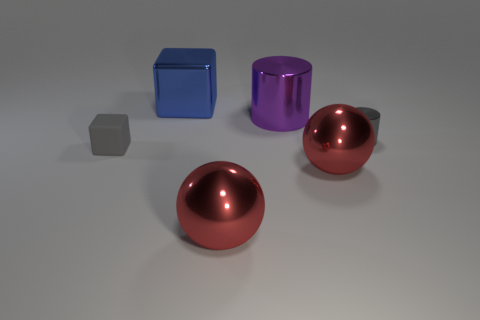There is a metallic object that is the same color as the tiny rubber object; what is its size?
Keep it short and to the point. Small. There is a tiny block; is its color the same as the tiny object that is on the right side of the large blue shiny cube?
Provide a short and direct response. Yes. What color is the large thing that is both on the right side of the shiny block and behind the gray cube?
Provide a short and direct response. Purple. How many purple shiny cylinders are behind the large block?
Keep it short and to the point. 0. What number of things are green metal objects or small objects left of the large blue metal block?
Offer a terse response. 1. There is a shiny cube left of the tiny gray cylinder; is there a big red sphere that is left of it?
Your answer should be very brief. No. There is a block that is behind the tiny gray cube; what color is it?
Give a very brief answer. Blue. Is the number of tiny gray matte cubes behind the small metal cylinder the same as the number of big gray matte balls?
Provide a succinct answer. Yes. What shape is the thing that is behind the small matte thing and right of the purple cylinder?
Provide a succinct answer. Cylinder. What is the color of the other small object that is the same shape as the purple object?
Offer a very short reply. Gray. 